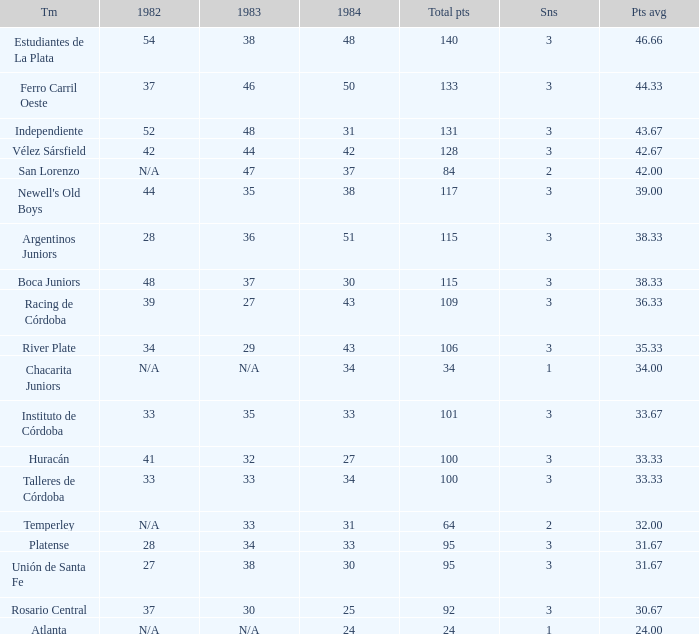What team had 3 seasons and fewer than 27 in 1984? Rosario Central. 